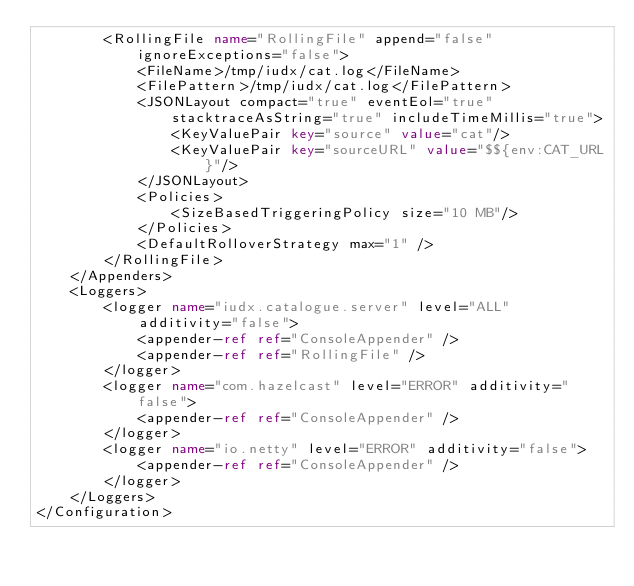Convert code to text. <code><loc_0><loc_0><loc_500><loc_500><_XML_>		<RollingFile name="RollingFile" append="false" ignoreExceptions="false">
            <FileName>/tmp/iudx/cat.log</FileName>
            <FilePattern>/tmp/iudx/cat.log</FilePattern>
            <JSONLayout compact="true" eventEol="true" stacktraceAsString="true" includeTimeMillis="true">
                <KeyValuePair key="source" value="cat"/>
                <KeyValuePair key="sourceURL" value="$${env:CAT_URL}"/>
            </JSONLayout>
			<Policies>
				<SizeBasedTriggeringPolicy size="10 MB"/>
			</Policies>
			<DefaultRolloverStrategy max="1" />
		</RollingFile>
    </Appenders>
    <Loggers>
        <logger name="iudx.catalogue.server" level="ALL"
            additivity="false">
            <appender-ref ref="ConsoleAppender" />
			<appender-ref ref="RollingFile" />
        </logger>
        <logger name="com.hazelcast" level="ERROR" additivity="false">
            <appender-ref ref="ConsoleAppender" />
        </logger>
        <logger name="io.netty" level="ERROR" additivity="false">
            <appender-ref ref="ConsoleAppender" />
        </logger>
    </Loggers>
</Configuration>
</code> 